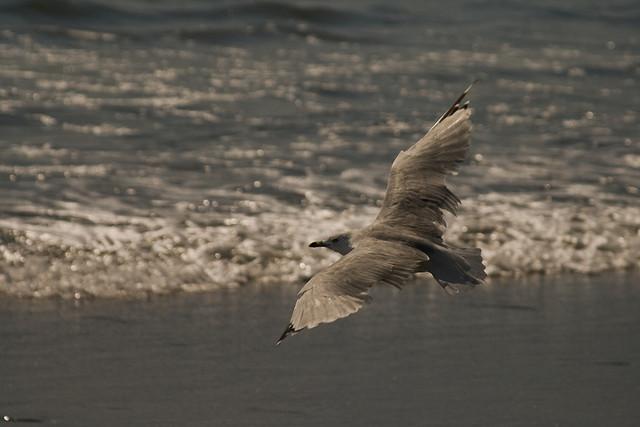What kind of animal is this?
Keep it brief. Seagull. Is this near the water?
Concise answer only. Yes. Where is the bird?
Short answer required. Beach. What is this bird called?
Quick response, please. Seagull. What color are the bird's tail feathers?
Answer briefly. Gray. 